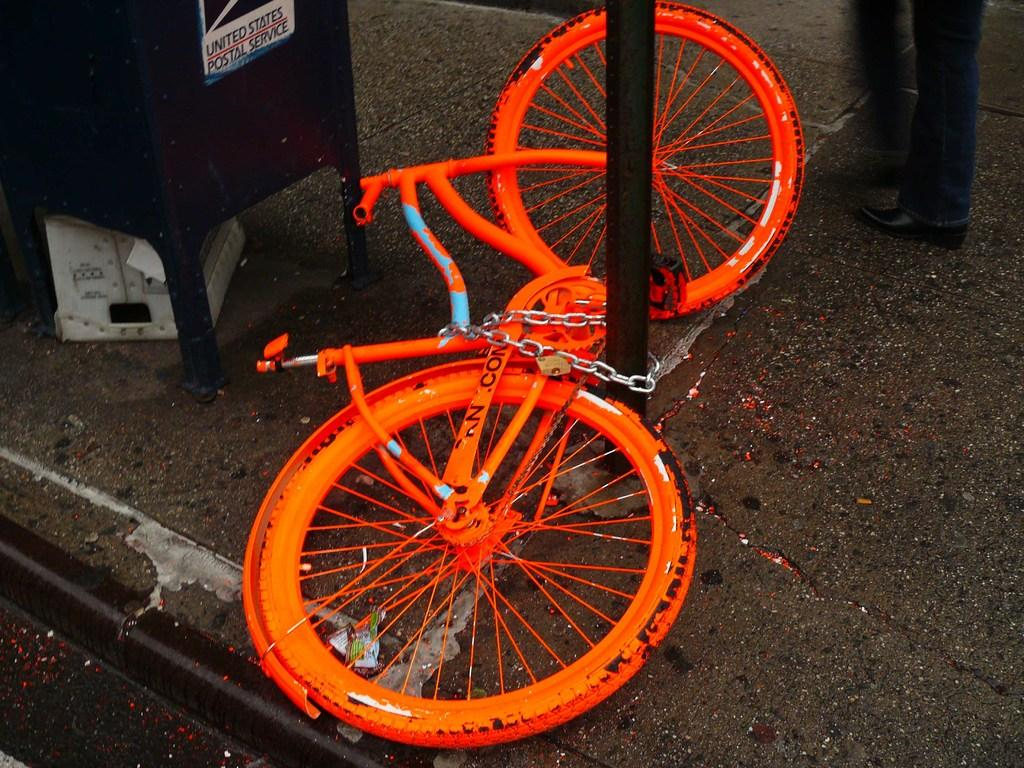What color is the bicycle in the image? The bicycle in the image is orange. What feature is present on the bicycle? There is a chain on the bicycle. What is the tall, vertical object in the image? There is a pole in the image. Who is present in the image? There is a person standing in the image. What else can be seen in the image besides the bicycle, pole, and person? There are some objects in the image. What type of acoustics can be heard from the bicycle in the image? There is no mention of acoustics in the image, as it features a bicycle, a pole, and a person. --- Facts: 1. There is a red car in the image. 2. The car has four wheels. 3. There is a person standing next to the car. 4. The person is holding a bag. 5. There is a building in the background. Absurd Topics: elephant, piano, concert Conversation: What type of vehicle is in the image? There is a red car in the image. How many wheels does the car have? The car has four wheels. Who is present in the image? There is a person standing next to the car. What is the person holding? The person is holding a bag. What can be seen in the background? There is a building in the background. Reasoning: Let's think step by step in order to produce the conversation. We start by identifying the main subject of the image, which is the red car. Next, we describe specific features of the car, such as the number of wheels it has. Then, we observe the actions of the person in the image, noting that they are standing next to the car and holding a bag. Finally, we describe the background of the image, which includes a building. Absurd Question/Answer: What type of elephant can be seen playing the piano in the image? There is no mention of an elephant or a piano in the image. The image features a red car, a person standing next to the car, and a building in the background. --- Facts: 1. There is a group of people in the image. 2. The people are wearing colorful clothes. 3. The people are holding hands. 4. There is a large tree in the background. 5. The sky is visible and blue. Absurd Topics: ice cream, refrigerator, kitchen Conversation: How many people are in the image? There is a group of people in the image. What are the people wearing? The people are wearing colorful clothes. What are the people doing in the image? The people are holding hands. 